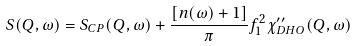<formula> <loc_0><loc_0><loc_500><loc_500>S ( Q , \omega ) = S _ { C P } ( { Q } , \omega ) + \frac { [ n ( \omega ) + 1 ] } { \pi } f _ { 1 } ^ { 2 } \chi _ { D H O } ^ { \prime \prime } ( { Q } , \omega )</formula> 